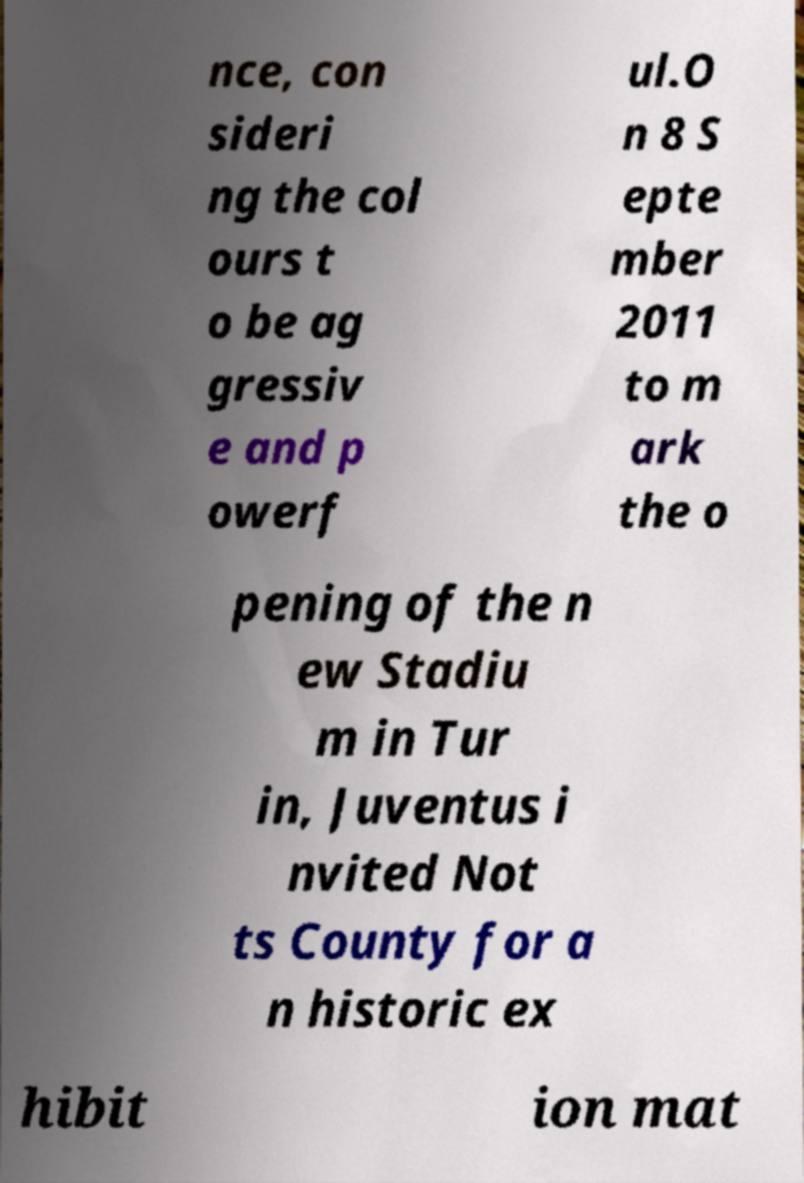For documentation purposes, I need the text within this image transcribed. Could you provide that? nce, con sideri ng the col ours t o be ag gressiv e and p owerf ul.O n 8 S epte mber 2011 to m ark the o pening of the n ew Stadiu m in Tur in, Juventus i nvited Not ts County for a n historic ex hibit ion mat 